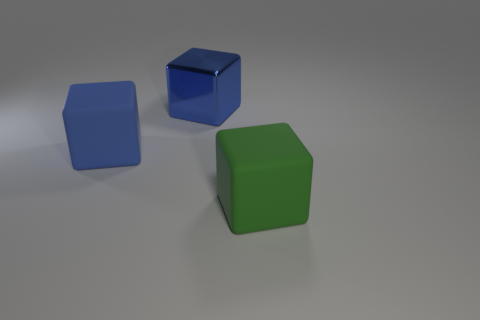If this scene were part of a puzzle game, how might the cubes be used? In a puzzle game context, these cubes could serve various functions. For instance, each could represent a different element or resource that the player needs to collect and combine strategically. Alternatively, they might need to be arranged in a certain pattern or stacked to reach a certain height to unlock the next level. 